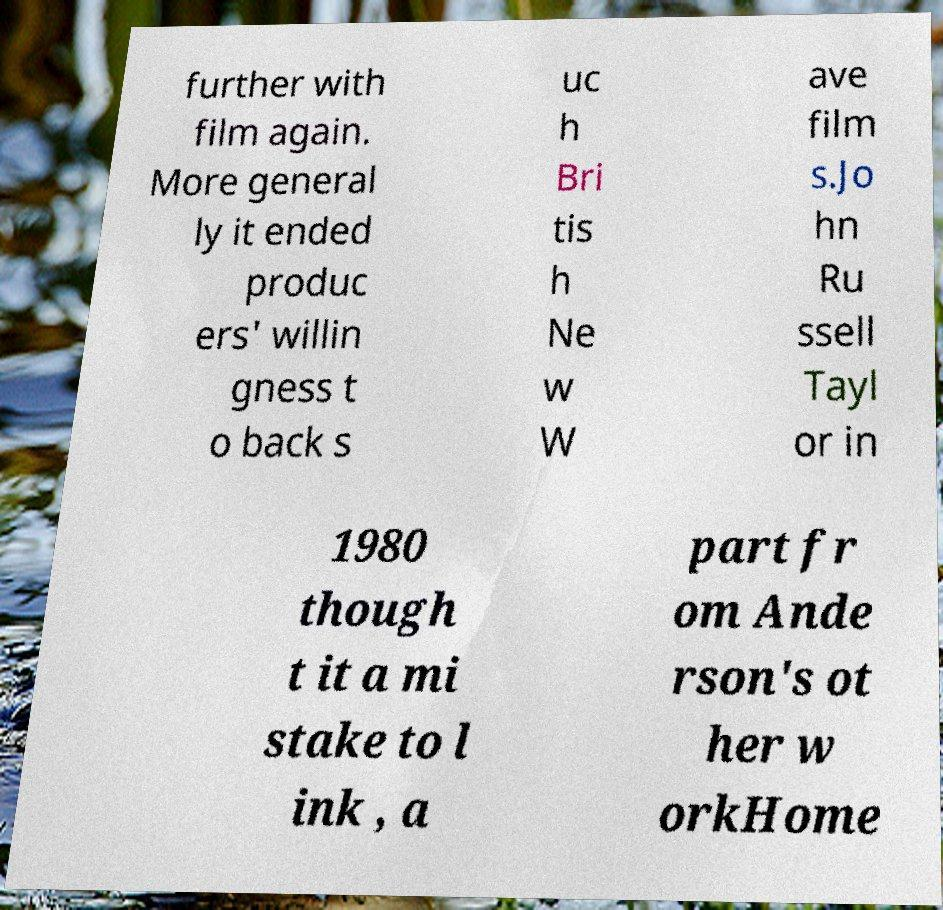For documentation purposes, I need the text within this image transcribed. Could you provide that? further with film again. More general ly it ended produc ers' willin gness t o back s uc h Bri tis h Ne w W ave film s.Jo hn Ru ssell Tayl or in 1980 though t it a mi stake to l ink , a part fr om Ande rson's ot her w orkHome 